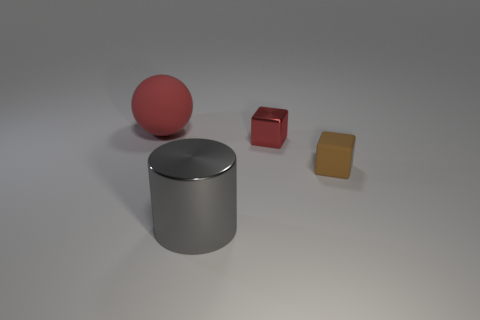Subtract 1 blocks. How many blocks are left? 1 Add 1 small brown matte spheres. How many objects exist? 5 Subtract all brown blocks. How many blocks are left? 1 Add 4 big things. How many big things exist? 6 Subtract 1 gray cylinders. How many objects are left? 3 Subtract all balls. How many objects are left? 3 Subtract all cyan cylinders. Subtract all red spheres. How many cylinders are left? 1 Subtract all purple cylinders. How many cyan spheres are left? 0 Subtract all large blue matte objects. Subtract all brown cubes. How many objects are left? 3 Add 1 cylinders. How many cylinders are left? 2 